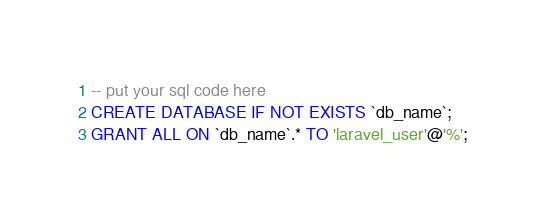Convert code to text. <code><loc_0><loc_0><loc_500><loc_500><_SQL_>-- put your sql code here
CREATE DATABASE IF NOT EXISTS `db_name`;
GRANT ALL ON `db_name`.* TO 'laravel_user'@'%';
</code> 